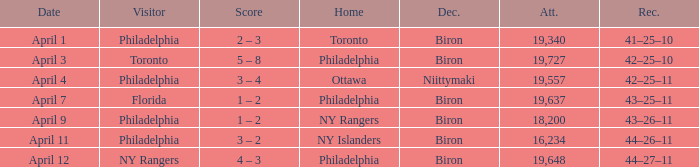What was the flyers' record when the visitors were florida? 43–25–11. 